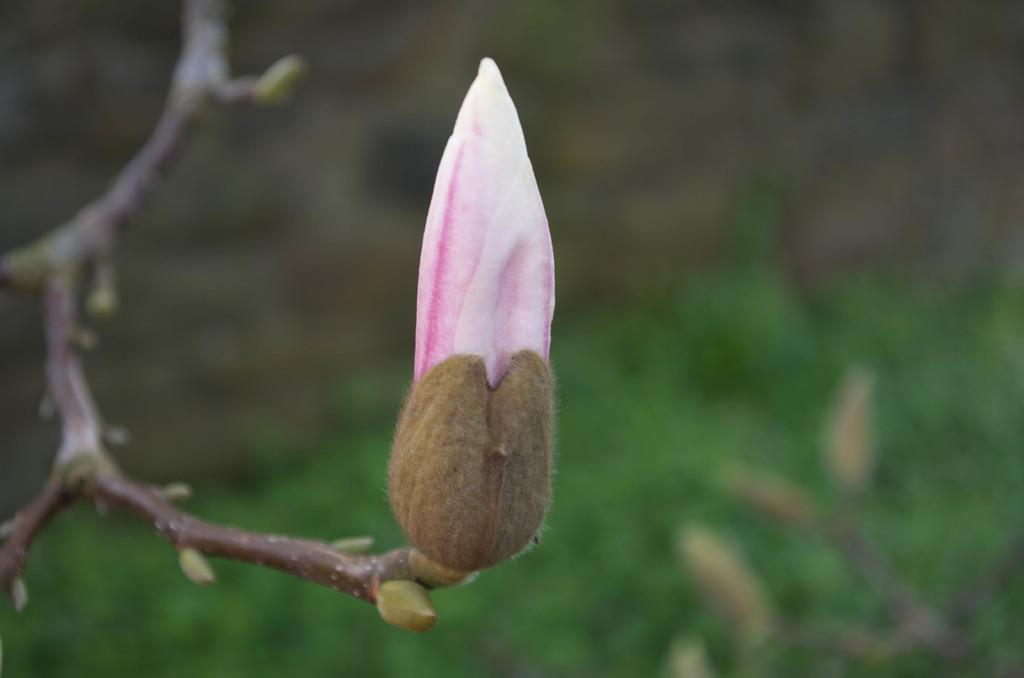What is the main subject of the image? The main subject of the image is a bud. Can you describe the background of the image? The background of the image is blurred. What is the name of the person who created the bud in the image? There is no information about the person who created the bud in the image, and the image does not depict a person. 